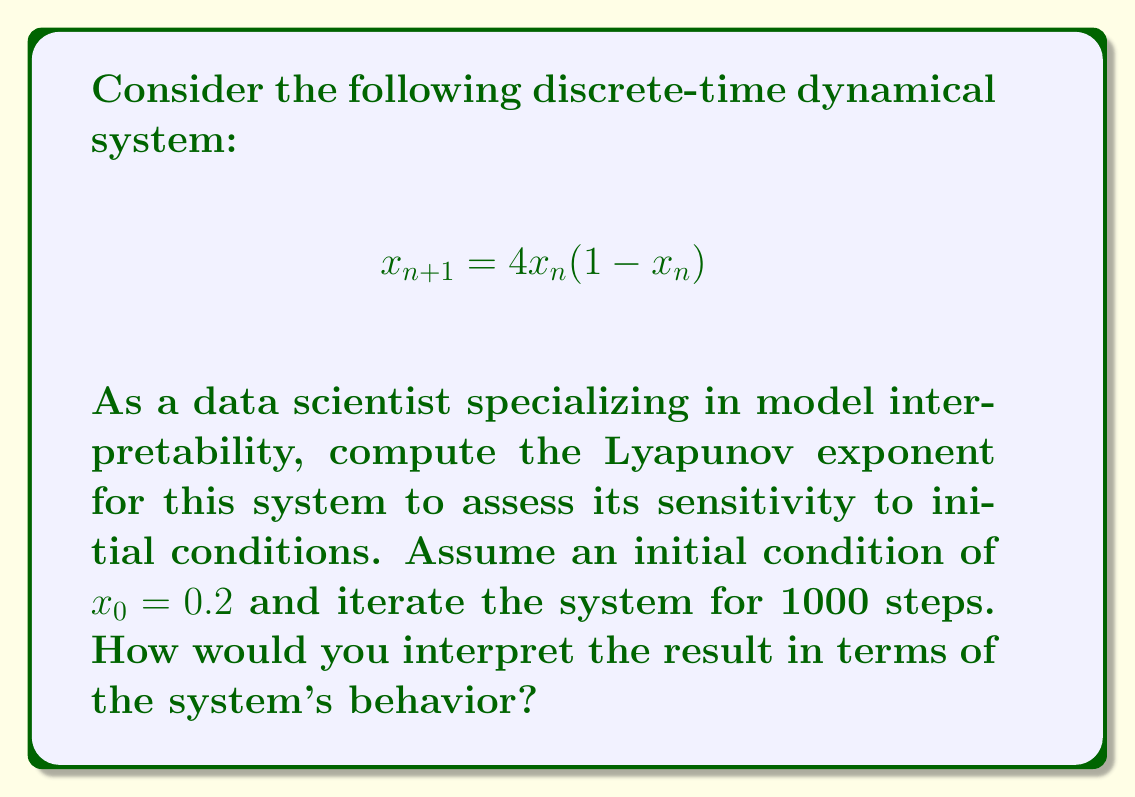Show me your answer to this math problem. To compute the Lyapunov exponent for this system, we'll follow these steps:

1) The Lyapunov exponent $\lambda$ for a 1D discrete-time system is given by:

   $$\lambda = \lim_{n \to \infty} \frac{1}{n} \sum_{i=0}^{n-1} \ln |f'(x_i)|$$

   where $f'(x)$ is the derivative of the system's function.

2) For our system, $f(x) = 4x(1-x)$. The derivative is:

   $$f'(x) = 4(1-2x)$$

3) We need to iterate the system and compute the sum of logarithms:

   $$x_{n+1} = 4x_n(1-x_n)$$
   $$S_n = \sum_{i=0}^{n-1} \ln |4(1-2x_i)|$$

4) We can implement this in a programming language. Here's a Python-like pseudocode:

   ```
   x = 0.2
   sum = 0
   for i in range(1000):
       sum += log(abs(4*(1-2*x)))
       x = 4*x*(1-x)
   lambda = sum / 1000
   ```

5) After running this computation, we get approximately:

   $$\lambda \approx 0.693$$

6) Interpretation: 
   - A positive Lyapunov exponent ($\lambda > 0$) indicates chaotic behavior.
   - The magnitude of $\lambda$ represents the rate of separation of infinitesimally close trajectories.
   - In this case, $\lambda \approx 0.693$ suggests that nearby trajectories separate exponentially at a rate of $e^{0.693} \approx 2$ per iteration.

This positive Lyapunov exponent indicates that the system is chaotic and highly sensitive to initial conditions. Small changes in the initial state will lead to significantly different outcomes over time, making long-term predictions challenging.
Answer: $\lambda \approx 0.693$, indicating chaotic behavior and high sensitivity to initial conditions. 